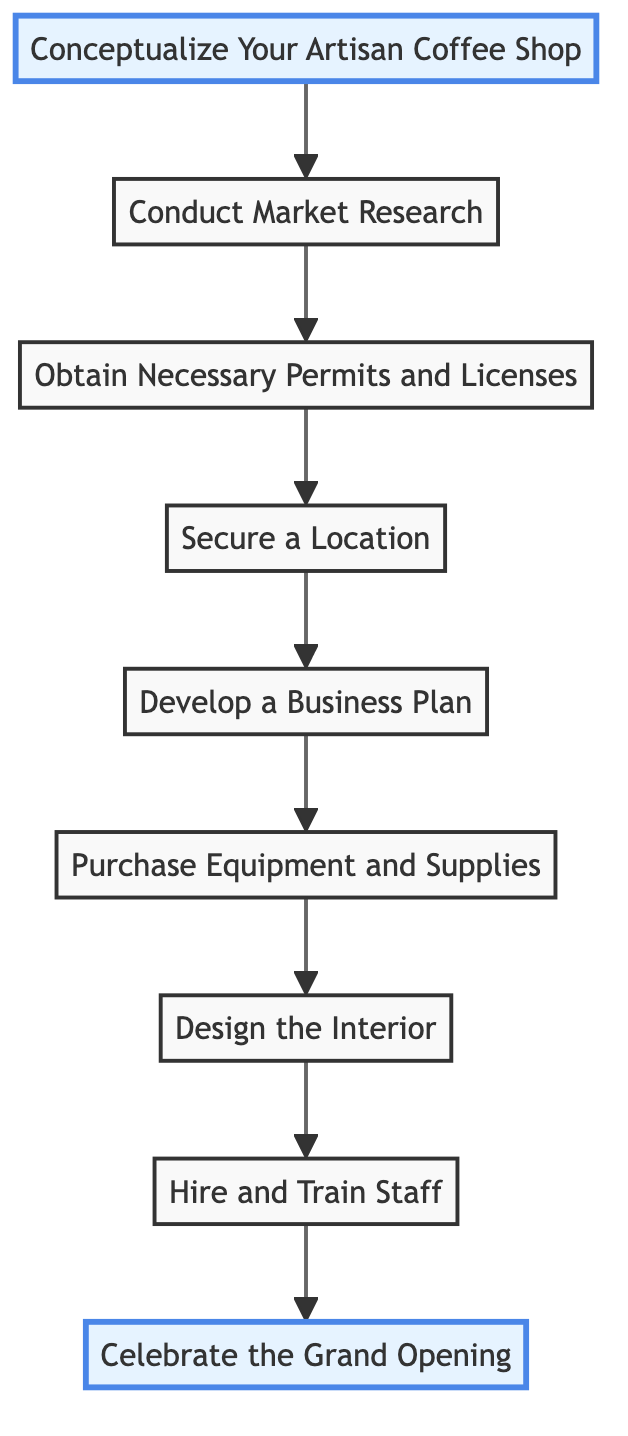What is the first step in the flowchart? The first step is titled "Conceptualize Your Artisan Coffee Shop," which is the starting point of the flow.
Answer: Conceptualize Your Artisan Coffee Shop How many steps are there in the flowchart? There are a total of eight steps represented in the flowchart detailing the process from initial idea to grand opening.
Answer: Eight What is the last step before celebrating the grand opening? The last step before the grand opening is "Hire and Train Staff," as it leads directly to the celebration.
Answer: Hire and Train Staff Which step involves securing permissions? The step that involves obtaining permissions is "Obtain Necessary Permits and Licenses," which ensures compliance before moving forward.
Answer: Obtain Necessary Permits and Licenses What two steps are directly connected to securing a location? The two steps directly connected to securing a location are "Obtain Necessary Permits and Licenses" (coming before it) and "Develop a Business Plan" (coming after it).
Answer: Obtain Necessary Permits and Licenses; Develop a Business Plan What is the relationship between conceptualizing your artisan coffee shop and hiring staff? The relationship is sequential; "Conceptualize Your Artisan Coffee Shop" is the first step, which leads to conducting market research, and eventually to "Hire and Train Staff" as part of the process.
Answer: Sequential What step comes immediately after purchasing equipment and supplies? The step that comes immediately after "Purchase Equipment and Supplies" is "Design the Interior," which builds on having the necessary equipment.
Answer: Design the Interior What characterizes the grand opening step? The "Celebrate the Grand Opening" step emphasizes hosting a launch event with local discounts and memorabilia to attract customers.
Answer: Launch event with discounts and memorabilia 